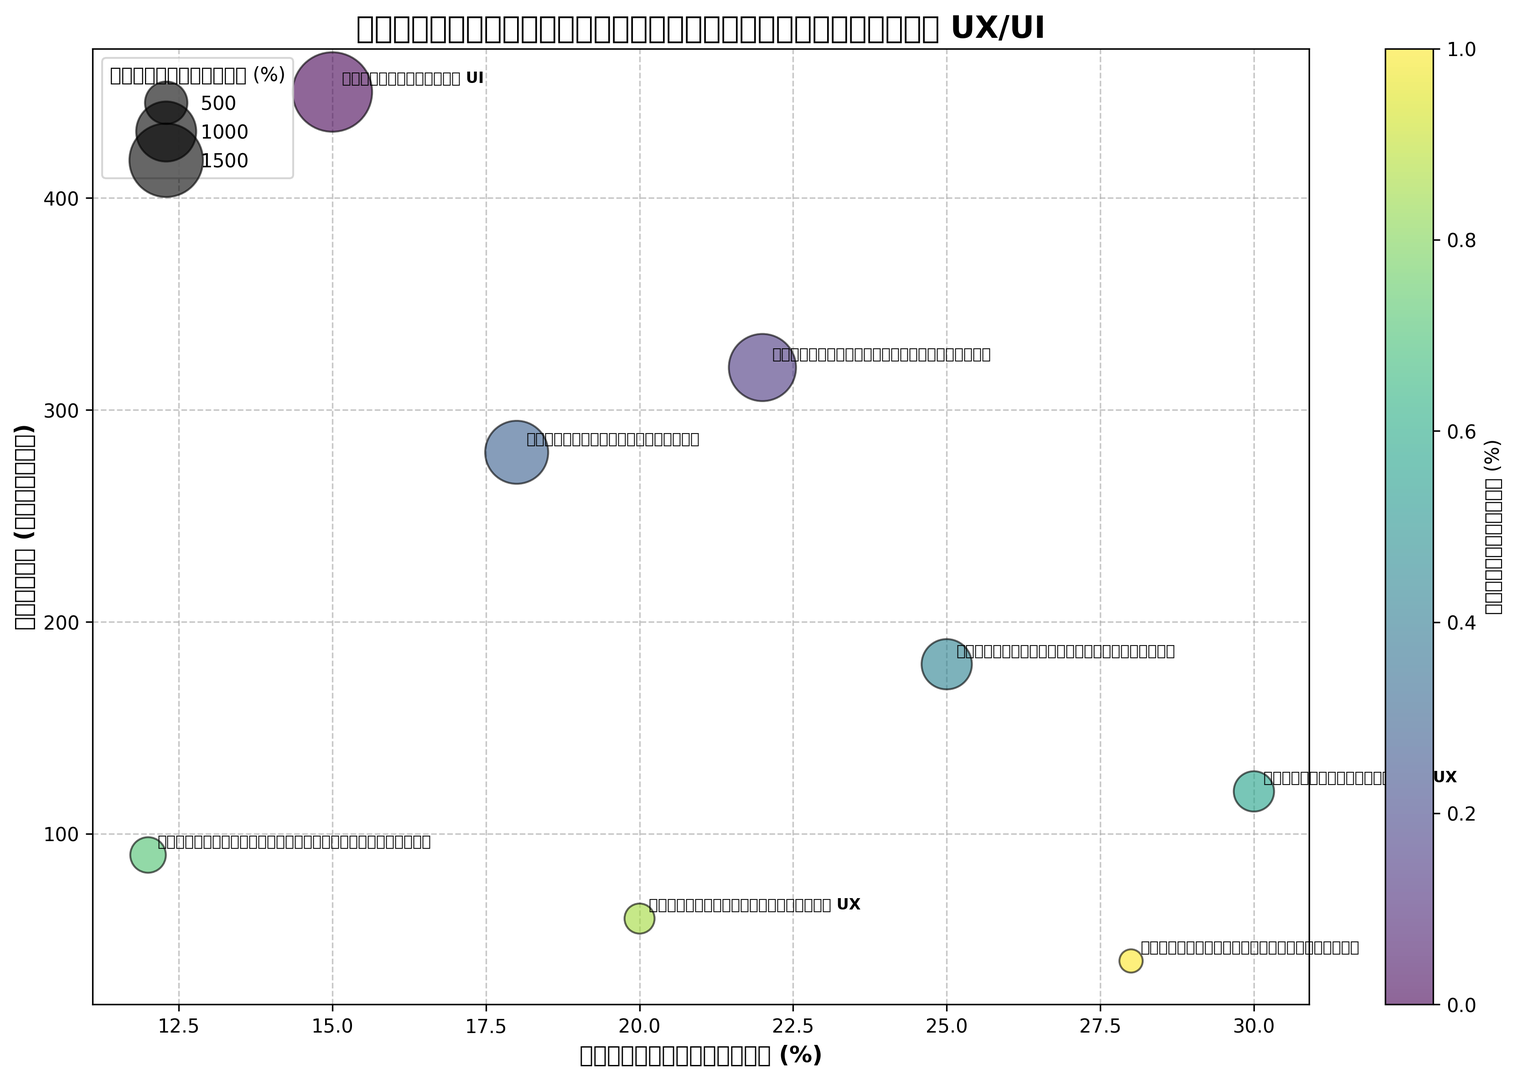which tool has the highest sales? The bubble with the largest value on the y-axis represents the tool with the highest sales. The program named "โปรแกรมออกแบบ UI" has the highest sales with a value of 450 ล้าน บาท.
Answer: โปรแกรมออกแบบ UI Which tool has the highest growth rate? The bubble that is furthest to the right on the x-axis represents the tool with the highest growth rate. "ซอฟต์แวร์วิเคราะห์ UX" has the highest growth rate at 30%.
Answer: ซอฟต์แวร์วิเคราะห์ UX Which tool has the largest market share? The size of the bubbles indicates the market share. The largest bubble corresponds to "โปรแกรมออกแบบ UI" with a market share of 35%.
Answer: โปรแกรมออกแบบ UI What's the sum of the sales of tools with a growth rate over 20%? Identify the tools with a growth rate over 20% ("เครื่องมือสร้างโปรโตไทป์", "เครื่องมือทดสอบการใช้งาน", "ซอฟต์แวร์วิเคราะห์ UX", "เครื่องมือสร้างแบบสอบถาม"), then sum their sales: 320 + 180 + 120 + 40 = 660 ล้าน บาท.
Answer: 660 Which tool has a lower sales value, "เครื่องมือสร้างโปรโตไทป์" or "ระบบจัดการงานออกแบบ"? Compare the y-values of the two tools. "ระบบจัดการงานออกแบบ" has a sales value of 280 ล้าน บาท, which is lower than "เครื่องมือสร้างโปรโตไทป์" with 320 ล้าน บาท.
Answer: ระบบจัดการงานออกแบบ What is the average sales value of tools with a market share below 10%? Tools with a market share below 10% are "ซอฟต์แวร์วิเคราะห์ UX", "เครื่องมือสร้างแผนผังโครงสร้าง", "ซอฟต์แวร์สร้างเอกสาร UX", and "เครื่องมือสร้างแบบสอบถาม". Their sales are 120, 90, 60, 40, respectively. Average = (120 + 90 + 60 + 40) / 4 = 77.5 ล้าน บาท.
Answer: 77.5 How many tools have a market share greater than 20%? Count the number of bubbles with a size representing a market share greater than 20%. The tools are "โปรแกรมออกแบบ UI", "เครื่องมือสร้างโปรโตไทป์", and "ระบบจัดการงานออกแบบ", totaling 3 tools.
Answer: 3 What is the difference in growth rate between "เครื่องมือสร้างแบบสอบถาม" and "เครื่องมือสร้างแผนผังโครงสร้าง"? The growth rate for "เครื่องมือสร้างแบบสอบถาม" is 28%, and for "เครื่องมือสร้างแผนผังโครงสร้าง" it is 12%. Difference = 28% - 12% = 16%.
Answer: 16% 